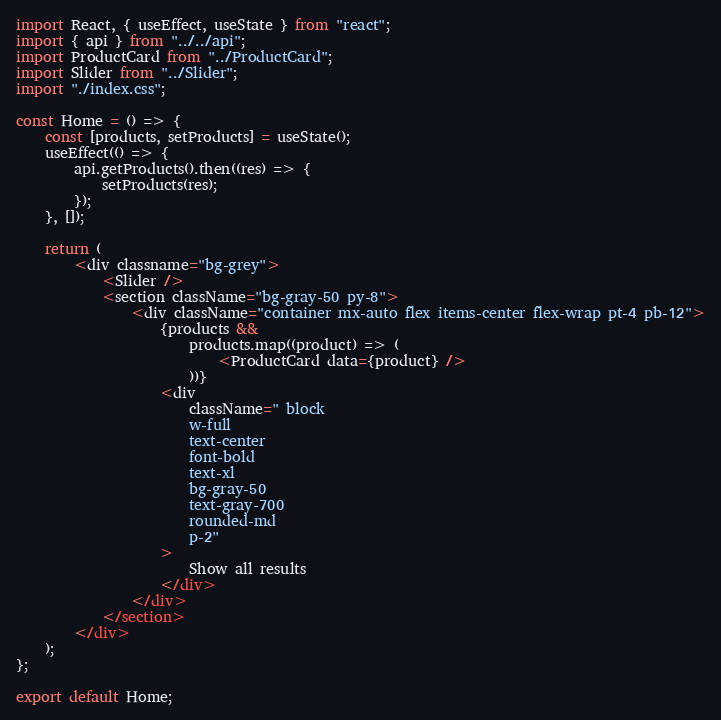Convert code to text. <code><loc_0><loc_0><loc_500><loc_500><_JavaScript_>import React, { useEffect, useState } from "react";
import { api } from "../../api";
import ProductCard from "../ProductCard";
import Slider from "../Slider";
import "./index.css";

const Home = () => {
    const [products, setProducts] = useState();
    useEffect(() => {
        api.getProducts().then((res) => {
            setProducts(res);
        });
    }, []);

    return (
        <div classname="bg-grey">
            <Slider />
            <section className="bg-gray-50 py-8">
                <div className="container mx-auto flex items-center flex-wrap pt-4 pb-12">
                    {products &&
                        products.map((product) => (
                            <ProductCard data={product} />
                        ))}
                    <div
                        className=" block
                        w-full
                        text-center
                        font-bold
                        text-xl
                        bg-gray-50
                        text-gray-700
                        rounded-md
                        p-2"
                    >
                        Show all results
                    </div>
                </div>
            </section>
        </div>
    );
};

export default Home;
</code> 